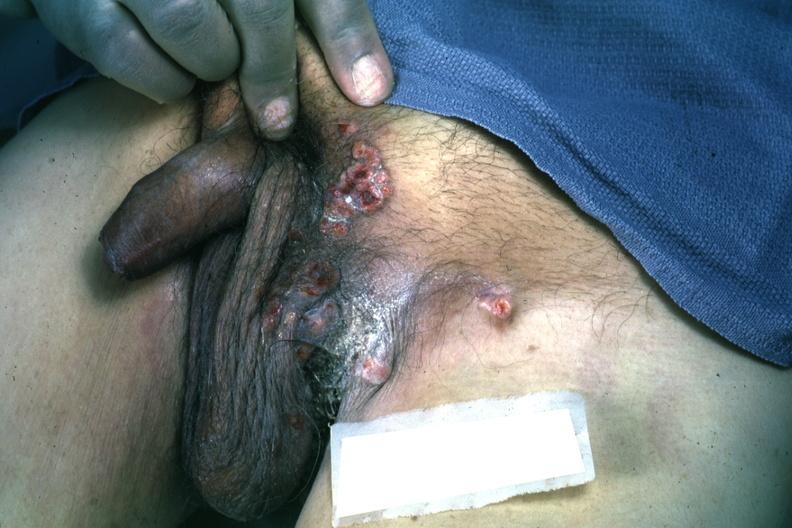where is this?
Answer the question using a single word or phrase. Skin 